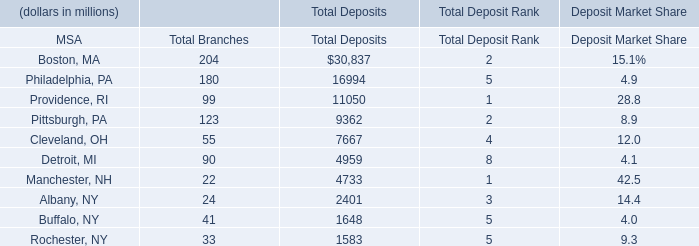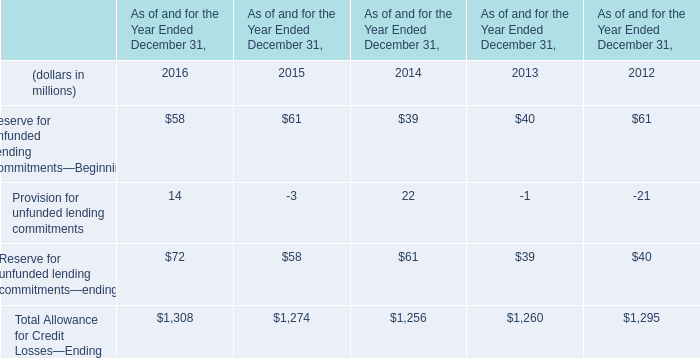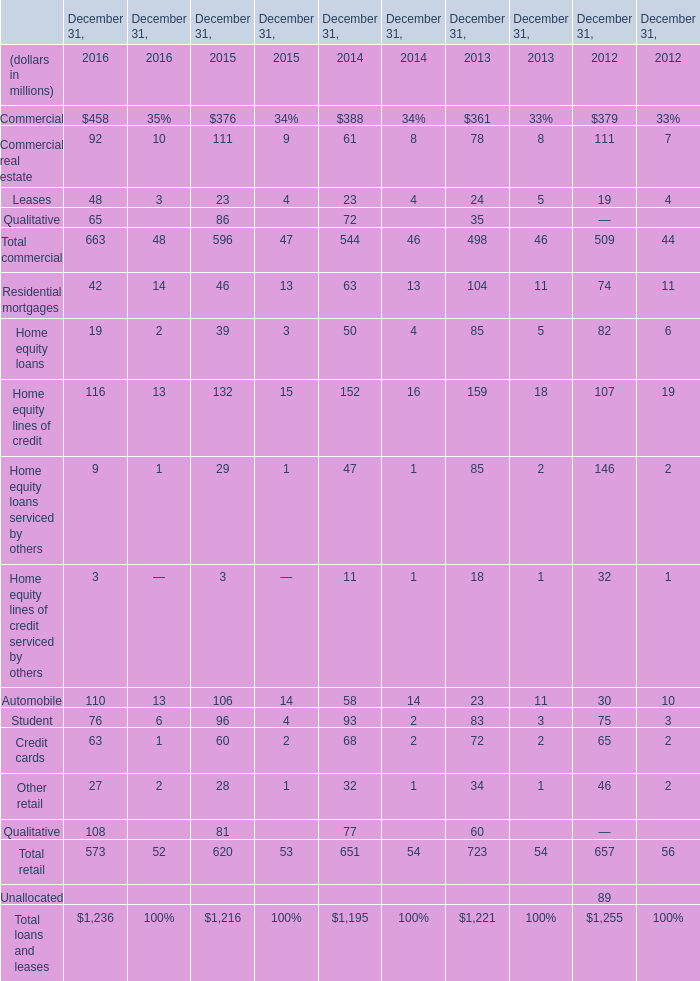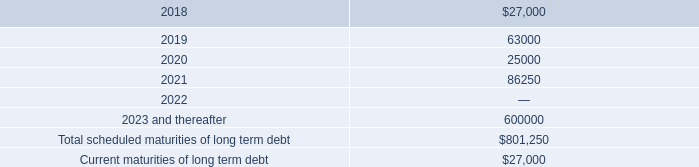what is the percentage increase in interest expense from 2016 to 2017? 
Computations: ((34.5 - 26.4) / 26.4)
Answer: 0.30682. 